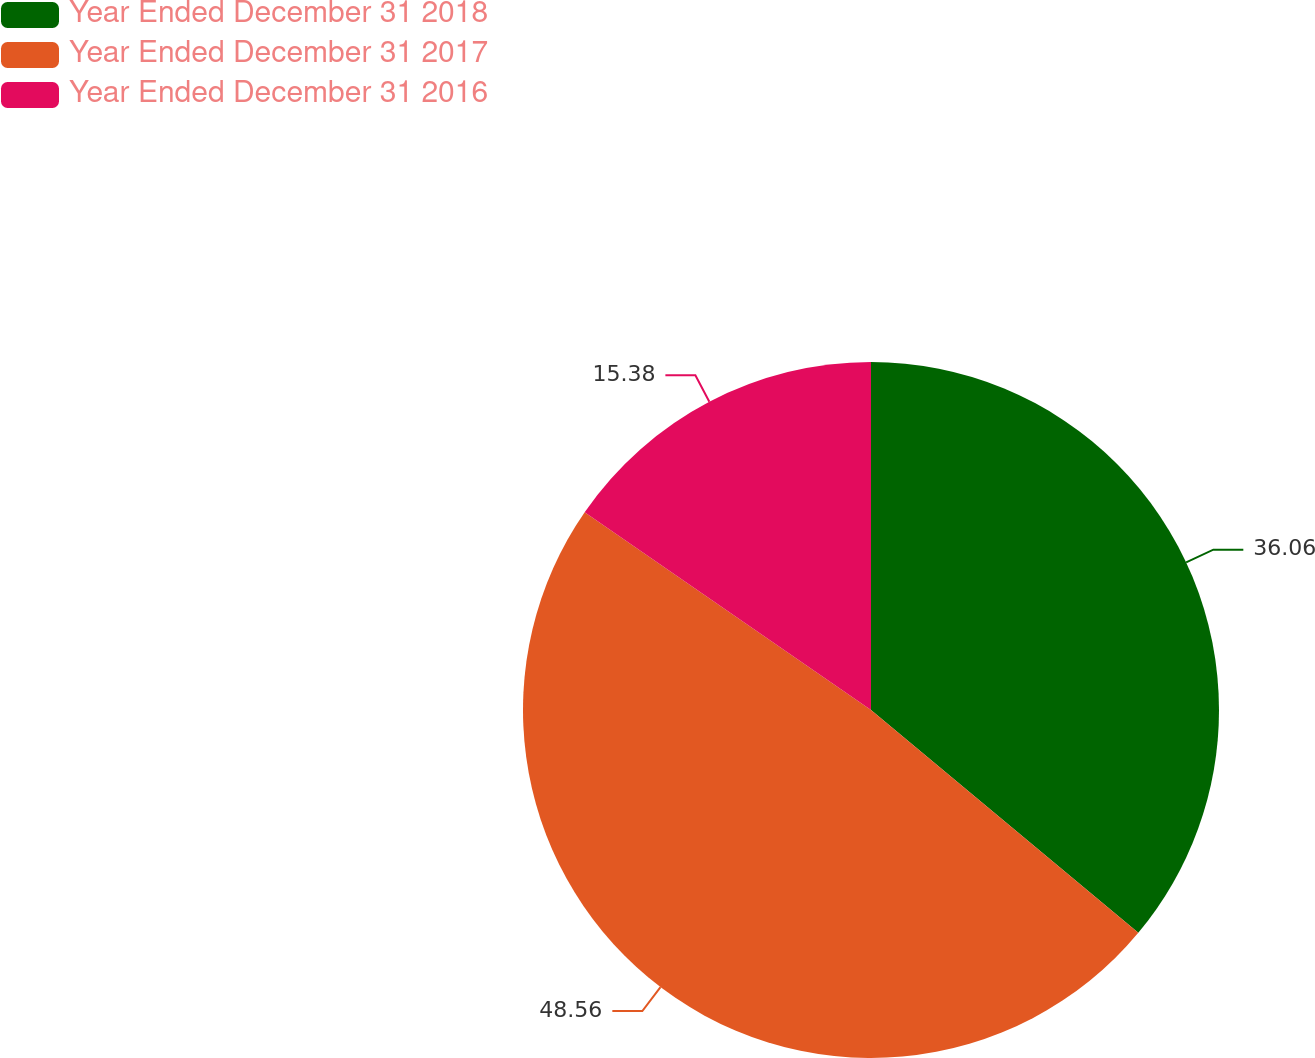Convert chart. <chart><loc_0><loc_0><loc_500><loc_500><pie_chart><fcel>Year Ended December 31 2018<fcel>Year Ended December 31 2017<fcel>Year Ended December 31 2016<nl><fcel>36.06%<fcel>48.56%<fcel>15.38%<nl></chart> 